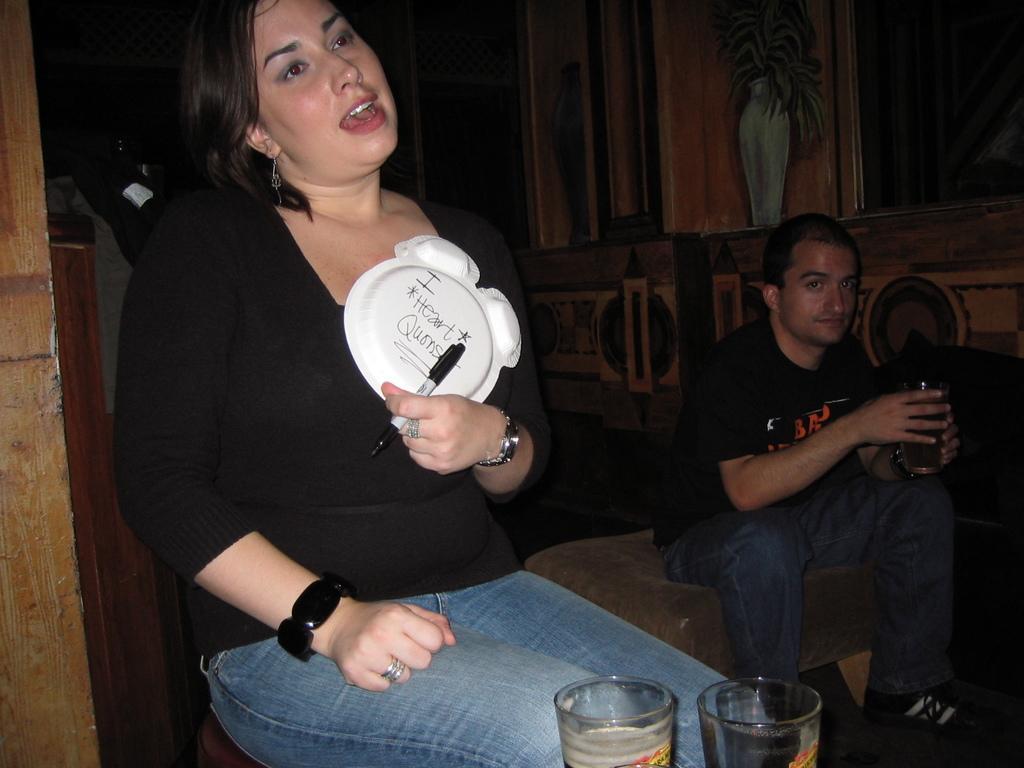Could you give a brief overview of what you see in this image? In this picture we can see a man and a woman is sitting, this woman is holding a pen and a plate, a man on the right side is holding a glass of drink, we can see two glasses at the bottom, there is a dark background, we can see painting of a flower vase on the right side. 